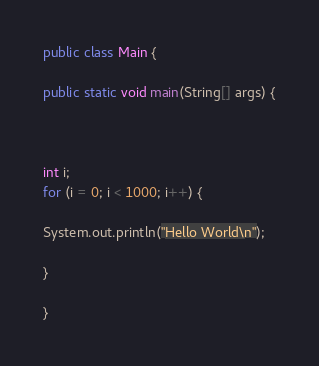Convert code to text. <code><loc_0><loc_0><loc_500><loc_500><_Java_>public class Main {

public static void main(String[] args) {



int i; 
for (i = 0; i < 1000; i++) {

System.out.println("Hello World\n");

}

}</code> 